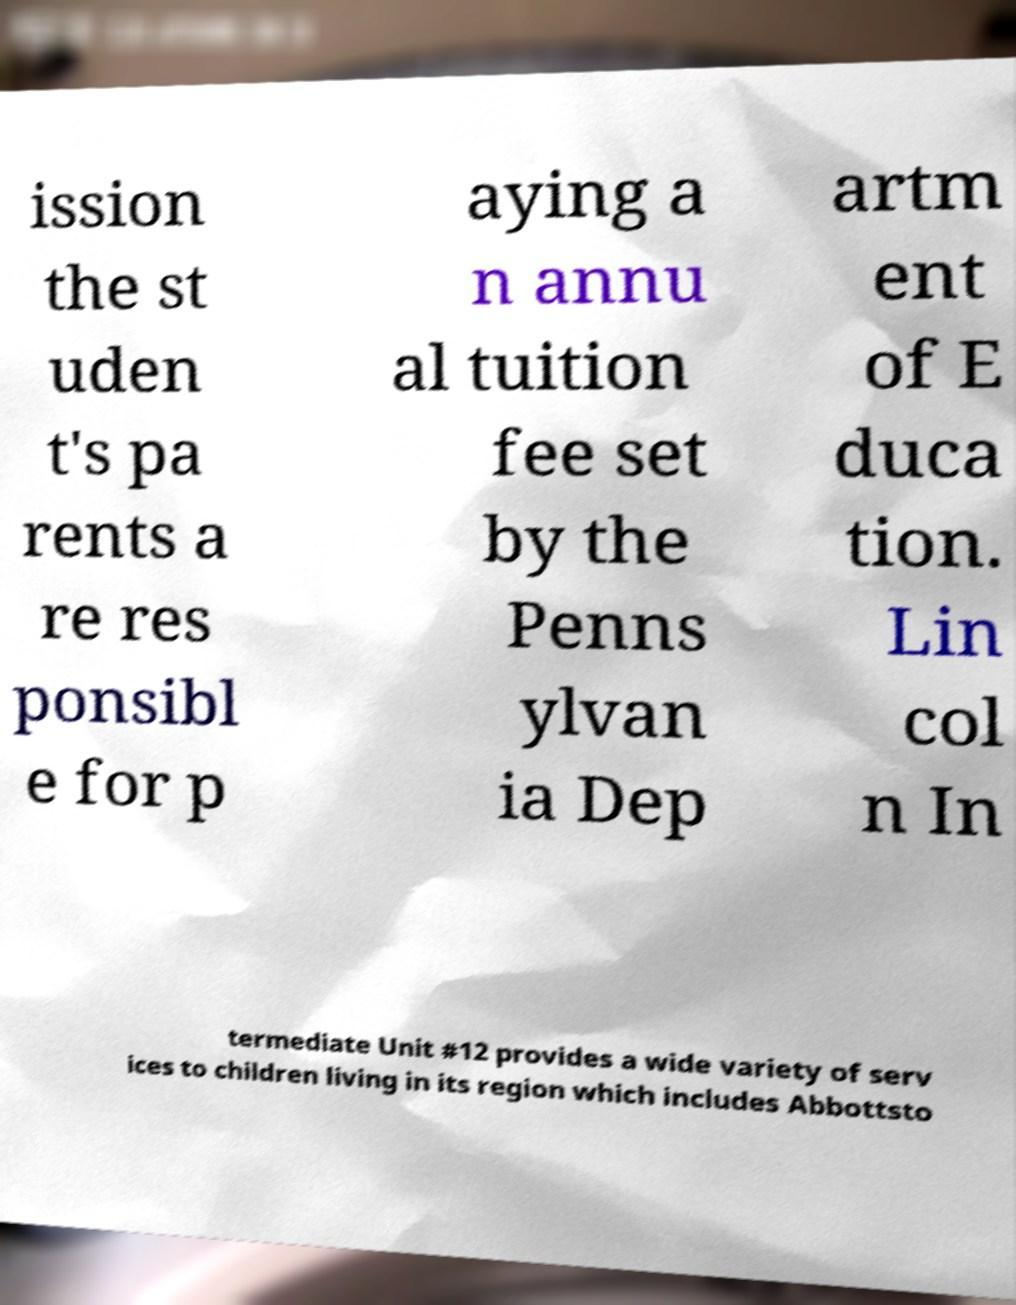For documentation purposes, I need the text within this image transcribed. Could you provide that? ission the st uden t's pa rents a re res ponsibl e for p aying a n annu al tuition fee set by the Penns ylvan ia Dep artm ent of E duca tion. Lin col n In termediate Unit #12 provides a wide variety of serv ices to children living in its region which includes Abbottsto 